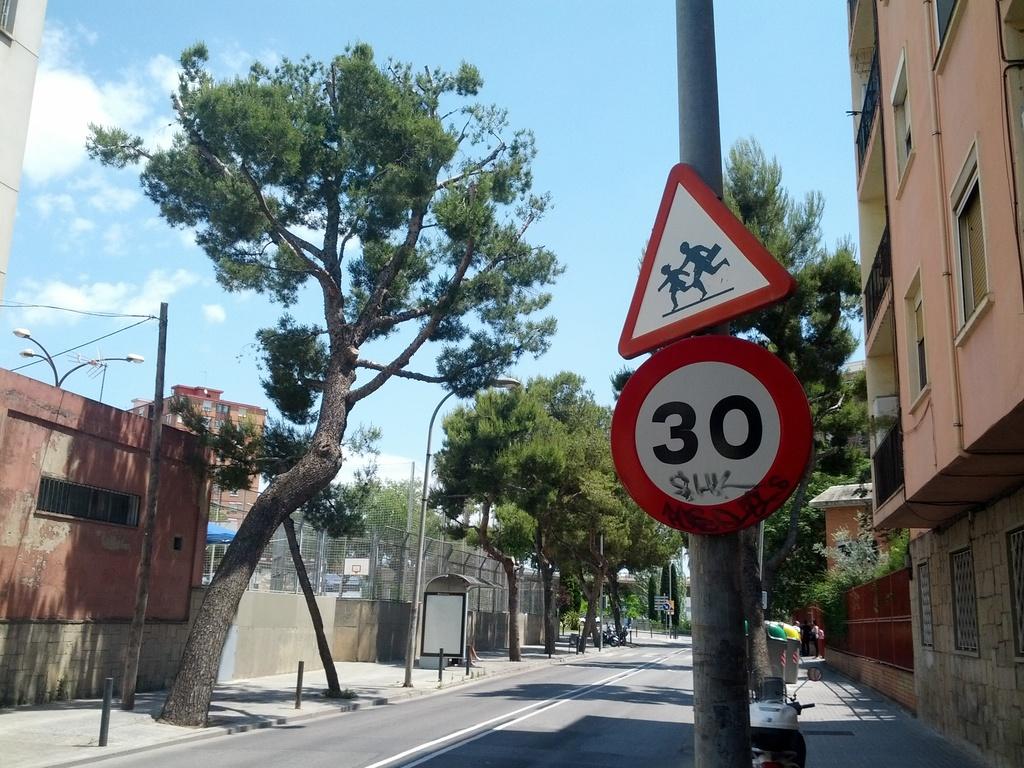What's the maximum speed allowed here?
Provide a succinct answer. 30. 